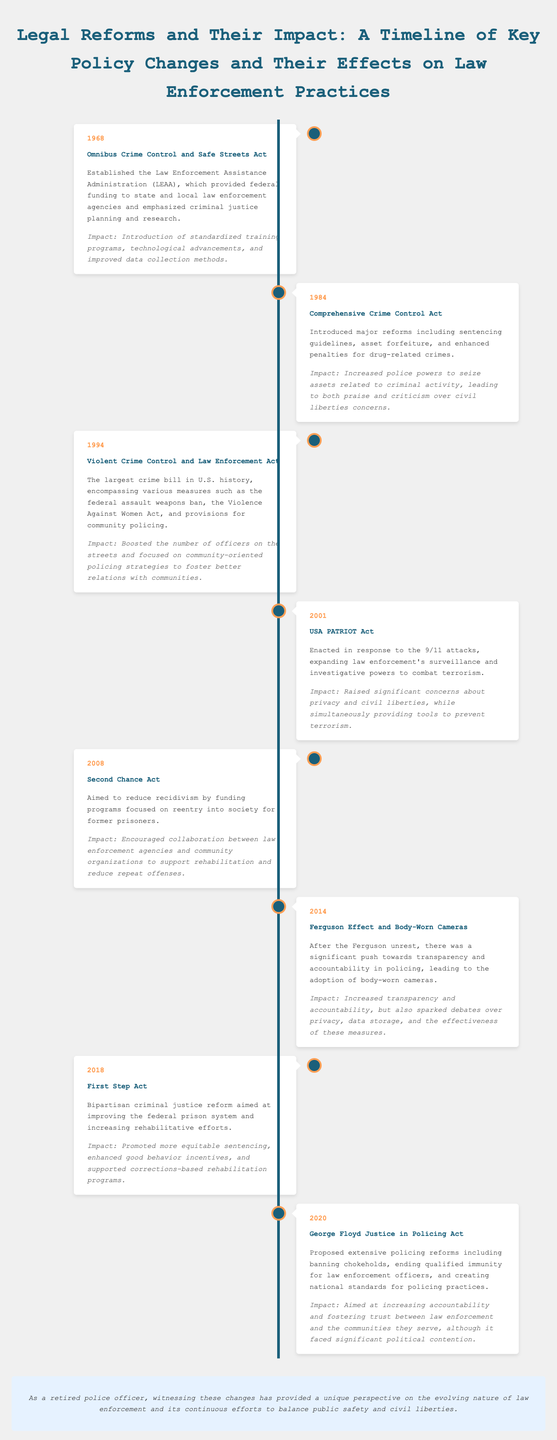what year was the Omnibus Crime Control and Safe Streets Act enacted? The document states that the Omnibus Crime Control and Safe Streets Act was enacted in 1968.
Answer: 1968 what was a significant impact of the Comprehensive Crime Control Act? The document notes that a significant impact of the Comprehensive Crime Control Act was increased police powers to seize assets related to criminal activity.
Answer: Increased police powers what year did the USA PATRIOT Act take effect? According to the timeline in the document, the USA PATRIOT Act took effect in 2001.
Answer: 2001 what reform aimed to reduce recidivism? The Second Chance Act aimed to reduce recidivism by funding programs focused on reentry into society for former prisoners.
Answer: Second Chance Act what major event prompted the adoption of body-worn cameras according to the timeline? The Ferguson unrest prompted the adoption of body-worn cameras, as stated in the document.
Answer: Ferguson unrest what was a key feature of the George Floyd Justice in Policing Act? A key feature of the George Floyd Justice in Policing Act was banning chokeholds.
Answer: Banning chokeholds which act was described as the largest crime bill in U.S. history? The Violent Crime Control and Law Enforcement Act is described as the largest crime bill in U.S. history.
Answer: Violent Crime Control and Law Enforcement Act how did the First Step Act aim to improve the federal prison system? The First Step Act aimed to improve the federal prison system by promoting more equitable sentencing and enhancing rehabilitative efforts.
Answer: More equitable sentencing what type of funding did the Law Enforcement Assistance Administration provide? The Law Enforcement Assistance Administration provided federal funding to state and local law enforcement agencies.
Answer: Federal funding 